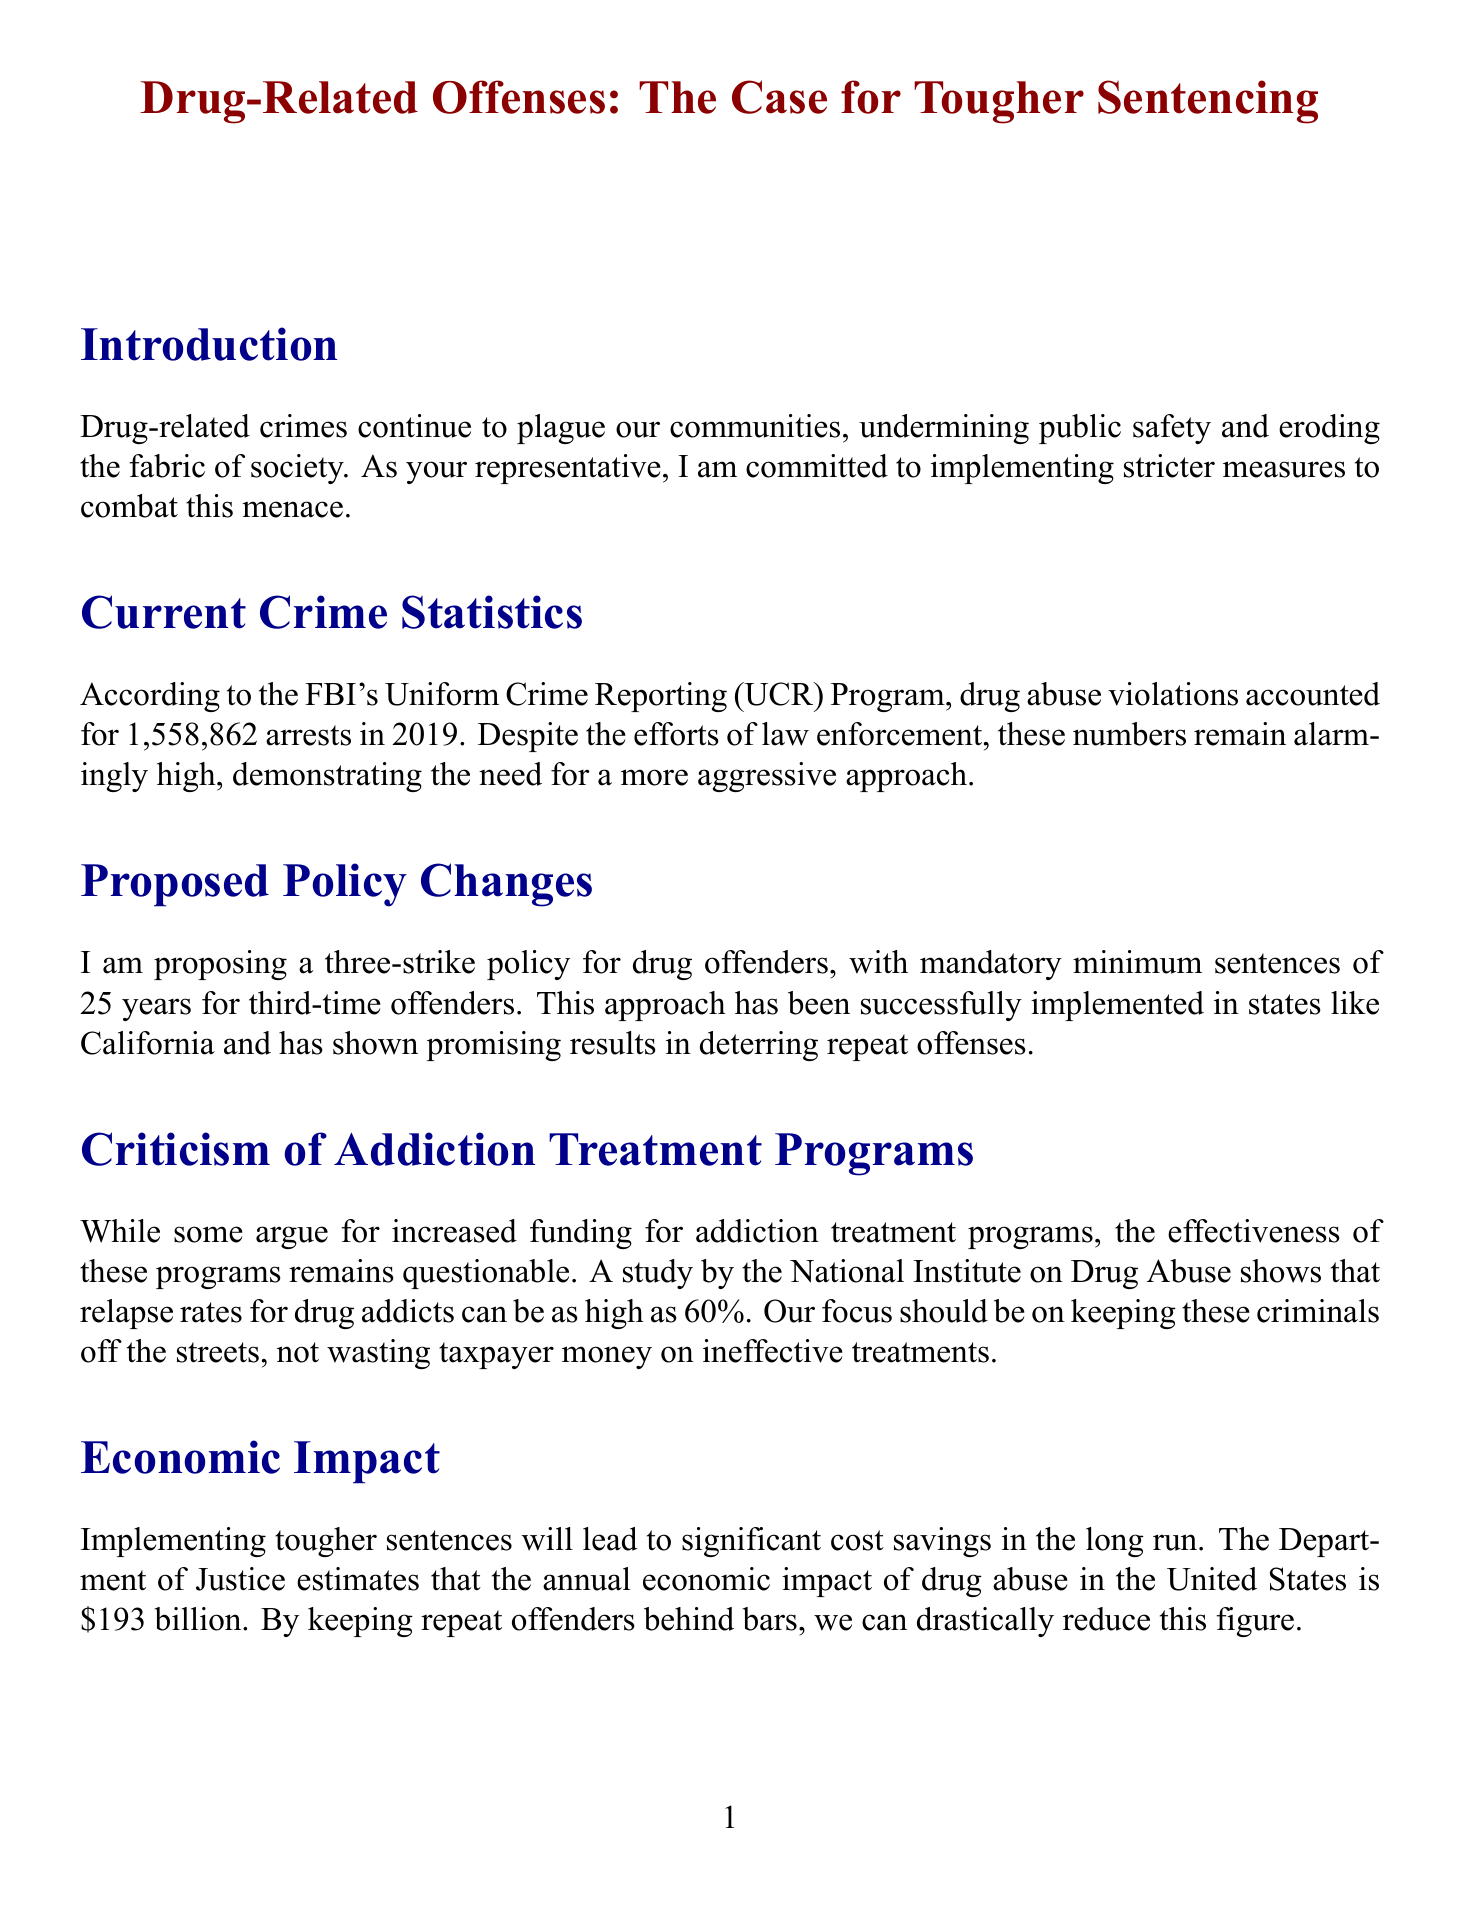What did drug abuse violations account for in 2019? The document states that drug abuse violations accounted for 1,558,862 arrests in 2019.
Answer: 1,558,862 arrests What is the proposed mandatory minimum sentence for third-time offenders? The proposed policy changes outline a mandatory minimum sentence of 25 years for third-time offenders.
Answer: 25 years Which organization reports the effectiveness of addiction treatment programs? The effectiveness of addiction treatment programs is questioned by a study from the National Institute on Drug Abuse.
Answer: National Institute on Drug Abuse What percentage of Americans believe the government is not doing enough to combat drug-related crimes? A recent Gallup poll revealed that 65% of Americans believe the government is not doing enough.
Answer: 65% What is the estimated annual economic impact of drug abuse in the United States? The Department of Justice estimates that the annual economic impact of drug abuse is $193 billion.
Answer: $193 billion What approach has been implemented in states like California? The document mentions a three-strike policy for drug offenders as being implemented in states like California.
Answer: three-strike policy Which countries are mentioned as having stricter drug laws? The document mentions Singapore and the United Arab Emirates as examples of countries with stricter drug laws.
Answer: Singapore, United Arab Emirates What is the main focus of the proposed policies? The main focus of the proposed policies is to keep repeat offenders off the streets.
Answer: keep repeat offenders off the streets 